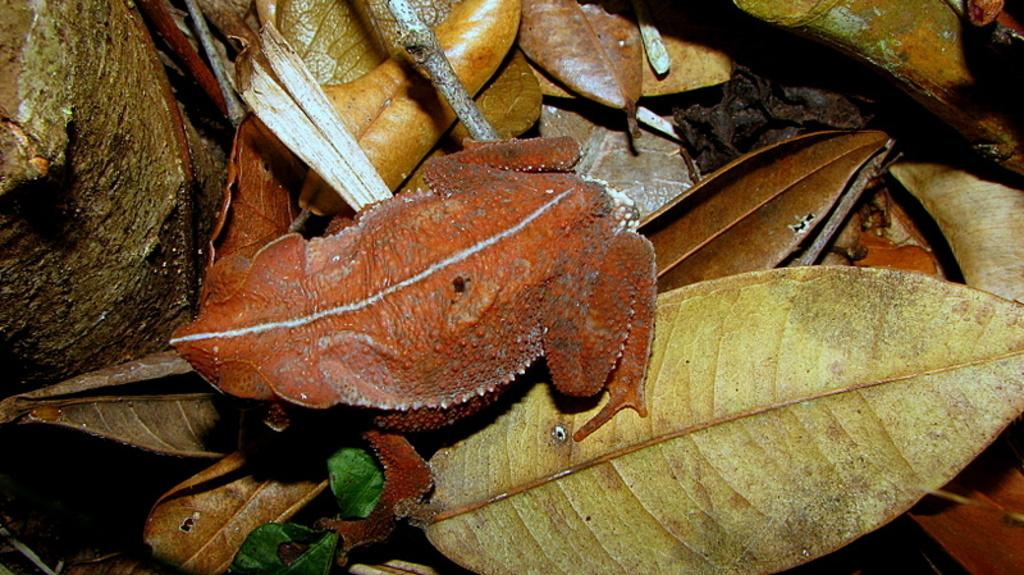What animal is present in the image? There is a frog in the image. What is the frog sitting on? The frog is on dried leaves. What can be seen on the left side of the image? There is a tree trunk on the left side of the image. What type of trade is happening in the image? There is no trade happening in the image; it features a frog on dried leaves with a tree trunk on the left side. Is there a stove visible in the image? No, there is no stove present in the image. 